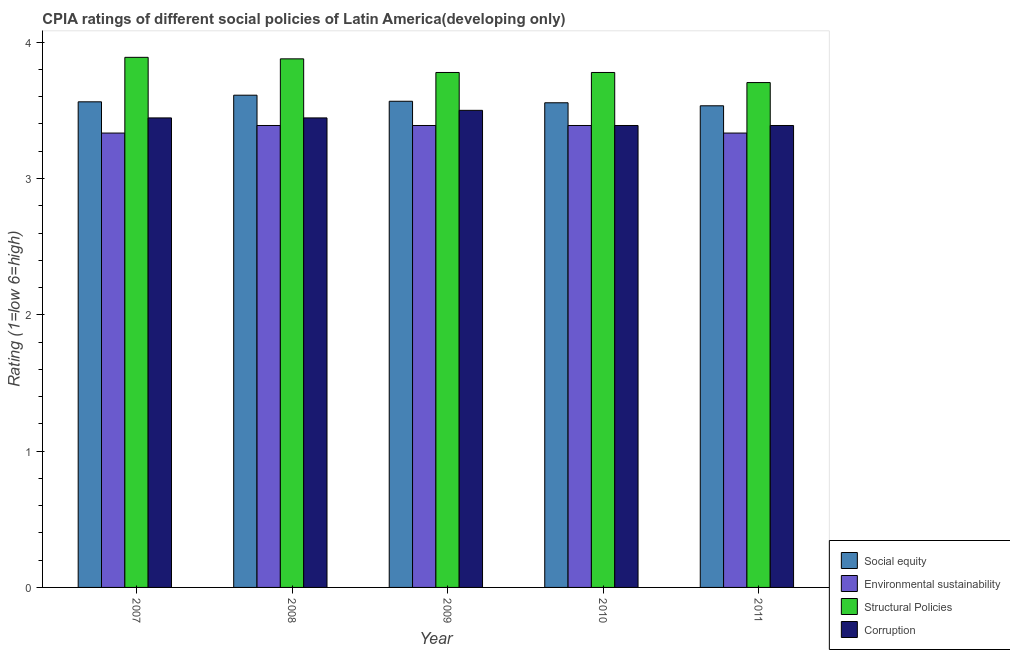How many different coloured bars are there?
Offer a very short reply. 4. Are the number of bars on each tick of the X-axis equal?
Your answer should be compact. Yes. What is the label of the 4th group of bars from the left?
Provide a succinct answer. 2010. In how many cases, is the number of bars for a given year not equal to the number of legend labels?
Keep it short and to the point. 0. What is the cpia rating of environmental sustainability in 2011?
Your answer should be compact. 3.33. Across all years, what is the maximum cpia rating of environmental sustainability?
Make the answer very short. 3.39. Across all years, what is the minimum cpia rating of corruption?
Provide a short and direct response. 3.39. In which year was the cpia rating of social equity maximum?
Provide a succinct answer. 2008. In which year was the cpia rating of structural policies minimum?
Your answer should be very brief. 2011. What is the total cpia rating of social equity in the graph?
Your response must be concise. 17.83. What is the difference between the cpia rating of social equity in 2009 and that in 2011?
Your answer should be compact. 0.03. What is the difference between the cpia rating of corruption in 2009 and the cpia rating of structural policies in 2007?
Your answer should be very brief. 0.06. What is the average cpia rating of corruption per year?
Provide a short and direct response. 3.43. In the year 2011, what is the difference between the cpia rating of social equity and cpia rating of structural policies?
Offer a terse response. 0. In how many years, is the cpia rating of environmental sustainability greater than 2.2?
Offer a terse response. 5. What is the ratio of the cpia rating of structural policies in 2009 to that in 2010?
Make the answer very short. 1. Is the cpia rating of social equity in 2007 less than that in 2010?
Keep it short and to the point. No. Is the difference between the cpia rating of social equity in 2008 and 2010 greater than the difference between the cpia rating of structural policies in 2008 and 2010?
Provide a succinct answer. No. What is the difference between the highest and the second highest cpia rating of corruption?
Your answer should be compact. 0.06. What is the difference between the highest and the lowest cpia rating of social equity?
Provide a succinct answer. 0.08. Is the sum of the cpia rating of social equity in 2007 and 2010 greater than the maximum cpia rating of structural policies across all years?
Provide a short and direct response. Yes. Is it the case that in every year, the sum of the cpia rating of environmental sustainability and cpia rating of structural policies is greater than the sum of cpia rating of social equity and cpia rating of corruption?
Give a very brief answer. No. What does the 3rd bar from the left in 2010 represents?
Give a very brief answer. Structural Policies. What does the 1st bar from the right in 2010 represents?
Keep it short and to the point. Corruption. Is it the case that in every year, the sum of the cpia rating of social equity and cpia rating of environmental sustainability is greater than the cpia rating of structural policies?
Your response must be concise. Yes. How many bars are there?
Make the answer very short. 20. How many years are there in the graph?
Give a very brief answer. 5. What is the difference between two consecutive major ticks on the Y-axis?
Your answer should be compact. 1. Does the graph contain any zero values?
Ensure brevity in your answer.  No. Does the graph contain grids?
Your response must be concise. No. Where does the legend appear in the graph?
Make the answer very short. Bottom right. How are the legend labels stacked?
Your answer should be very brief. Vertical. What is the title of the graph?
Your response must be concise. CPIA ratings of different social policies of Latin America(developing only). Does "International Development Association" appear as one of the legend labels in the graph?
Your answer should be compact. No. What is the label or title of the Y-axis?
Your answer should be very brief. Rating (1=low 6=high). What is the Rating (1=low 6=high) of Social equity in 2007?
Make the answer very short. 3.56. What is the Rating (1=low 6=high) of Environmental sustainability in 2007?
Make the answer very short. 3.33. What is the Rating (1=low 6=high) of Structural Policies in 2007?
Offer a very short reply. 3.89. What is the Rating (1=low 6=high) in Corruption in 2007?
Give a very brief answer. 3.44. What is the Rating (1=low 6=high) of Social equity in 2008?
Give a very brief answer. 3.61. What is the Rating (1=low 6=high) in Environmental sustainability in 2008?
Ensure brevity in your answer.  3.39. What is the Rating (1=low 6=high) of Structural Policies in 2008?
Offer a very short reply. 3.88. What is the Rating (1=low 6=high) of Corruption in 2008?
Offer a terse response. 3.44. What is the Rating (1=low 6=high) of Social equity in 2009?
Offer a terse response. 3.57. What is the Rating (1=low 6=high) of Environmental sustainability in 2009?
Keep it short and to the point. 3.39. What is the Rating (1=low 6=high) in Structural Policies in 2009?
Offer a very short reply. 3.78. What is the Rating (1=low 6=high) in Corruption in 2009?
Make the answer very short. 3.5. What is the Rating (1=low 6=high) of Social equity in 2010?
Your answer should be compact. 3.56. What is the Rating (1=low 6=high) of Environmental sustainability in 2010?
Keep it short and to the point. 3.39. What is the Rating (1=low 6=high) of Structural Policies in 2010?
Your answer should be very brief. 3.78. What is the Rating (1=low 6=high) of Corruption in 2010?
Your answer should be very brief. 3.39. What is the Rating (1=low 6=high) in Social equity in 2011?
Your answer should be compact. 3.53. What is the Rating (1=low 6=high) in Environmental sustainability in 2011?
Make the answer very short. 3.33. What is the Rating (1=low 6=high) in Structural Policies in 2011?
Offer a very short reply. 3.7. What is the Rating (1=low 6=high) in Corruption in 2011?
Offer a terse response. 3.39. Across all years, what is the maximum Rating (1=low 6=high) in Social equity?
Make the answer very short. 3.61. Across all years, what is the maximum Rating (1=low 6=high) of Environmental sustainability?
Provide a succinct answer. 3.39. Across all years, what is the maximum Rating (1=low 6=high) in Structural Policies?
Offer a very short reply. 3.89. Across all years, what is the maximum Rating (1=low 6=high) of Corruption?
Offer a terse response. 3.5. Across all years, what is the minimum Rating (1=low 6=high) of Social equity?
Your answer should be compact. 3.53. Across all years, what is the minimum Rating (1=low 6=high) in Environmental sustainability?
Offer a very short reply. 3.33. Across all years, what is the minimum Rating (1=low 6=high) of Structural Policies?
Provide a succinct answer. 3.7. Across all years, what is the minimum Rating (1=low 6=high) of Corruption?
Give a very brief answer. 3.39. What is the total Rating (1=low 6=high) in Social equity in the graph?
Ensure brevity in your answer.  17.83. What is the total Rating (1=low 6=high) in Environmental sustainability in the graph?
Keep it short and to the point. 16.83. What is the total Rating (1=low 6=high) of Structural Policies in the graph?
Provide a short and direct response. 19.03. What is the total Rating (1=low 6=high) of Corruption in the graph?
Provide a short and direct response. 17.17. What is the difference between the Rating (1=low 6=high) of Social equity in 2007 and that in 2008?
Your response must be concise. -0.05. What is the difference between the Rating (1=low 6=high) of Environmental sustainability in 2007 and that in 2008?
Offer a very short reply. -0.06. What is the difference between the Rating (1=low 6=high) of Structural Policies in 2007 and that in 2008?
Provide a succinct answer. 0.01. What is the difference between the Rating (1=low 6=high) of Corruption in 2007 and that in 2008?
Provide a short and direct response. 0. What is the difference between the Rating (1=low 6=high) of Social equity in 2007 and that in 2009?
Keep it short and to the point. -0. What is the difference between the Rating (1=low 6=high) of Environmental sustainability in 2007 and that in 2009?
Offer a terse response. -0.06. What is the difference between the Rating (1=low 6=high) in Structural Policies in 2007 and that in 2009?
Ensure brevity in your answer.  0.11. What is the difference between the Rating (1=low 6=high) of Corruption in 2007 and that in 2009?
Provide a short and direct response. -0.06. What is the difference between the Rating (1=low 6=high) in Social equity in 2007 and that in 2010?
Offer a very short reply. 0.01. What is the difference between the Rating (1=low 6=high) in Environmental sustainability in 2007 and that in 2010?
Give a very brief answer. -0.06. What is the difference between the Rating (1=low 6=high) in Structural Policies in 2007 and that in 2010?
Make the answer very short. 0.11. What is the difference between the Rating (1=low 6=high) in Corruption in 2007 and that in 2010?
Ensure brevity in your answer.  0.06. What is the difference between the Rating (1=low 6=high) of Social equity in 2007 and that in 2011?
Provide a short and direct response. 0.03. What is the difference between the Rating (1=low 6=high) of Environmental sustainability in 2007 and that in 2011?
Provide a short and direct response. 0. What is the difference between the Rating (1=low 6=high) in Structural Policies in 2007 and that in 2011?
Your response must be concise. 0.19. What is the difference between the Rating (1=low 6=high) in Corruption in 2007 and that in 2011?
Provide a short and direct response. 0.06. What is the difference between the Rating (1=low 6=high) in Social equity in 2008 and that in 2009?
Your answer should be very brief. 0.04. What is the difference between the Rating (1=low 6=high) of Corruption in 2008 and that in 2009?
Keep it short and to the point. -0.06. What is the difference between the Rating (1=low 6=high) in Social equity in 2008 and that in 2010?
Ensure brevity in your answer.  0.06. What is the difference between the Rating (1=low 6=high) of Structural Policies in 2008 and that in 2010?
Provide a succinct answer. 0.1. What is the difference between the Rating (1=low 6=high) in Corruption in 2008 and that in 2010?
Offer a terse response. 0.06. What is the difference between the Rating (1=low 6=high) in Social equity in 2008 and that in 2011?
Make the answer very short. 0.08. What is the difference between the Rating (1=low 6=high) of Environmental sustainability in 2008 and that in 2011?
Keep it short and to the point. 0.06. What is the difference between the Rating (1=low 6=high) in Structural Policies in 2008 and that in 2011?
Your answer should be very brief. 0.17. What is the difference between the Rating (1=low 6=high) of Corruption in 2008 and that in 2011?
Your answer should be very brief. 0.06. What is the difference between the Rating (1=low 6=high) of Social equity in 2009 and that in 2010?
Your response must be concise. 0.01. What is the difference between the Rating (1=low 6=high) in Corruption in 2009 and that in 2010?
Keep it short and to the point. 0.11. What is the difference between the Rating (1=low 6=high) in Environmental sustainability in 2009 and that in 2011?
Provide a succinct answer. 0.06. What is the difference between the Rating (1=low 6=high) in Structural Policies in 2009 and that in 2011?
Give a very brief answer. 0.07. What is the difference between the Rating (1=low 6=high) in Corruption in 2009 and that in 2011?
Provide a short and direct response. 0.11. What is the difference between the Rating (1=low 6=high) of Social equity in 2010 and that in 2011?
Your answer should be compact. 0.02. What is the difference between the Rating (1=low 6=high) in Environmental sustainability in 2010 and that in 2011?
Your response must be concise. 0.06. What is the difference between the Rating (1=low 6=high) of Structural Policies in 2010 and that in 2011?
Your response must be concise. 0.07. What is the difference between the Rating (1=low 6=high) of Social equity in 2007 and the Rating (1=low 6=high) of Environmental sustainability in 2008?
Your response must be concise. 0.17. What is the difference between the Rating (1=low 6=high) of Social equity in 2007 and the Rating (1=low 6=high) of Structural Policies in 2008?
Ensure brevity in your answer.  -0.32. What is the difference between the Rating (1=low 6=high) in Social equity in 2007 and the Rating (1=low 6=high) in Corruption in 2008?
Ensure brevity in your answer.  0.12. What is the difference between the Rating (1=low 6=high) in Environmental sustainability in 2007 and the Rating (1=low 6=high) in Structural Policies in 2008?
Provide a short and direct response. -0.54. What is the difference between the Rating (1=low 6=high) of Environmental sustainability in 2007 and the Rating (1=low 6=high) of Corruption in 2008?
Your response must be concise. -0.11. What is the difference between the Rating (1=low 6=high) of Structural Policies in 2007 and the Rating (1=low 6=high) of Corruption in 2008?
Ensure brevity in your answer.  0.44. What is the difference between the Rating (1=low 6=high) in Social equity in 2007 and the Rating (1=low 6=high) in Environmental sustainability in 2009?
Your response must be concise. 0.17. What is the difference between the Rating (1=low 6=high) in Social equity in 2007 and the Rating (1=low 6=high) in Structural Policies in 2009?
Your response must be concise. -0.22. What is the difference between the Rating (1=low 6=high) of Social equity in 2007 and the Rating (1=low 6=high) of Corruption in 2009?
Offer a very short reply. 0.06. What is the difference between the Rating (1=low 6=high) in Environmental sustainability in 2007 and the Rating (1=low 6=high) in Structural Policies in 2009?
Make the answer very short. -0.44. What is the difference between the Rating (1=low 6=high) of Environmental sustainability in 2007 and the Rating (1=low 6=high) of Corruption in 2009?
Provide a short and direct response. -0.17. What is the difference between the Rating (1=low 6=high) in Structural Policies in 2007 and the Rating (1=low 6=high) in Corruption in 2009?
Your response must be concise. 0.39. What is the difference between the Rating (1=low 6=high) of Social equity in 2007 and the Rating (1=low 6=high) of Environmental sustainability in 2010?
Your answer should be compact. 0.17. What is the difference between the Rating (1=low 6=high) of Social equity in 2007 and the Rating (1=low 6=high) of Structural Policies in 2010?
Offer a terse response. -0.22. What is the difference between the Rating (1=low 6=high) of Social equity in 2007 and the Rating (1=low 6=high) of Corruption in 2010?
Your answer should be compact. 0.17. What is the difference between the Rating (1=low 6=high) in Environmental sustainability in 2007 and the Rating (1=low 6=high) in Structural Policies in 2010?
Ensure brevity in your answer.  -0.44. What is the difference between the Rating (1=low 6=high) of Environmental sustainability in 2007 and the Rating (1=low 6=high) of Corruption in 2010?
Provide a short and direct response. -0.06. What is the difference between the Rating (1=low 6=high) in Structural Policies in 2007 and the Rating (1=low 6=high) in Corruption in 2010?
Your answer should be very brief. 0.5. What is the difference between the Rating (1=low 6=high) in Social equity in 2007 and the Rating (1=low 6=high) in Environmental sustainability in 2011?
Provide a succinct answer. 0.23. What is the difference between the Rating (1=low 6=high) of Social equity in 2007 and the Rating (1=low 6=high) of Structural Policies in 2011?
Provide a short and direct response. -0.14. What is the difference between the Rating (1=low 6=high) of Social equity in 2007 and the Rating (1=low 6=high) of Corruption in 2011?
Offer a terse response. 0.17. What is the difference between the Rating (1=low 6=high) in Environmental sustainability in 2007 and the Rating (1=low 6=high) in Structural Policies in 2011?
Offer a very short reply. -0.37. What is the difference between the Rating (1=low 6=high) of Environmental sustainability in 2007 and the Rating (1=low 6=high) of Corruption in 2011?
Keep it short and to the point. -0.06. What is the difference between the Rating (1=low 6=high) in Social equity in 2008 and the Rating (1=low 6=high) in Environmental sustainability in 2009?
Offer a terse response. 0.22. What is the difference between the Rating (1=low 6=high) in Environmental sustainability in 2008 and the Rating (1=low 6=high) in Structural Policies in 2009?
Your answer should be compact. -0.39. What is the difference between the Rating (1=low 6=high) of Environmental sustainability in 2008 and the Rating (1=low 6=high) of Corruption in 2009?
Offer a very short reply. -0.11. What is the difference between the Rating (1=low 6=high) in Structural Policies in 2008 and the Rating (1=low 6=high) in Corruption in 2009?
Offer a very short reply. 0.38. What is the difference between the Rating (1=low 6=high) of Social equity in 2008 and the Rating (1=low 6=high) of Environmental sustainability in 2010?
Give a very brief answer. 0.22. What is the difference between the Rating (1=low 6=high) of Social equity in 2008 and the Rating (1=low 6=high) of Corruption in 2010?
Your answer should be very brief. 0.22. What is the difference between the Rating (1=low 6=high) in Environmental sustainability in 2008 and the Rating (1=low 6=high) in Structural Policies in 2010?
Give a very brief answer. -0.39. What is the difference between the Rating (1=low 6=high) in Environmental sustainability in 2008 and the Rating (1=low 6=high) in Corruption in 2010?
Offer a very short reply. 0. What is the difference between the Rating (1=low 6=high) in Structural Policies in 2008 and the Rating (1=low 6=high) in Corruption in 2010?
Your answer should be compact. 0.49. What is the difference between the Rating (1=low 6=high) in Social equity in 2008 and the Rating (1=low 6=high) in Environmental sustainability in 2011?
Keep it short and to the point. 0.28. What is the difference between the Rating (1=low 6=high) in Social equity in 2008 and the Rating (1=low 6=high) in Structural Policies in 2011?
Offer a terse response. -0.09. What is the difference between the Rating (1=low 6=high) of Social equity in 2008 and the Rating (1=low 6=high) of Corruption in 2011?
Provide a short and direct response. 0.22. What is the difference between the Rating (1=low 6=high) in Environmental sustainability in 2008 and the Rating (1=low 6=high) in Structural Policies in 2011?
Provide a short and direct response. -0.31. What is the difference between the Rating (1=low 6=high) of Structural Policies in 2008 and the Rating (1=low 6=high) of Corruption in 2011?
Make the answer very short. 0.49. What is the difference between the Rating (1=low 6=high) in Social equity in 2009 and the Rating (1=low 6=high) in Environmental sustainability in 2010?
Your answer should be very brief. 0.18. What is the difference between the Rating (1=low 6=high) of Social equity in 2009 and the Rating (1=low 6=high) of Structural Policies in 2010?
Ensure brevity in your answer.  -0.21. What is the difference between the Rating (1=low 6=high) in Social equity in 2009 and the Rating (1=low 6=high) in Corruption in 2010?
Give a very brief answer. 0.18. What is the difference between the Rating (1=low 6=high) of Environmental sustainability in 2009 and the Rating (1=low 6=high) of Structural Policies in 2010?
Your answer should be very brief. -0.39. What is the difference between the Rating (1=low 6=high) in Structural Policies in 2009 and the Rating (1=low 6=high) in Corruption in 2010?
Your response must be concise. 0.39. What is the difference between the Rating (1=low 6=high) in Social equity in 2009 and the Rating (1=low 6=high) in Environmental sustainability in 2011?
Give a very brief answer. 0.23. What is the difference between the Rating (1=low 6=high) in Social equity in 2009 and the Rating (1=low 6=high) in Structural Policies in 2011?
Your answer should be very brief. -0.14. What is the difference between the Rating (1=low 6=high) of Social equity in 2009 and the Rating (1=low 6=high) of Corruption in 2011?
Provide a succinct answer. 0.18. What is the difference between the Rating (1=low 6=high) of Environmental sustainability in 2009 and the Rating (1=low 6=high) of Structural Policies in 2011?
Keep it short and to the point. -0.31. What is the difference between the Rating (1=low 6=high) of Structural Policies in 2009 and the Rating (1=low 6=high) of Corruption in 2011?
Your response must be concise. 0.39. What is the difference between the Rating (1=low 6=high) of Social equity in 2010 and the Rating (1=low 6=high) of Environmental sustainability in 2011?
Ensure brevity in your answer.  0.22. What is the difference between the Rating (1=low 6=high) of Social equity in 2010 and the Rating (1=low 6=high) of Structural Policies in 2011?
Your answer should be very brief. -0.15. What is the difference between the Rating (1=low 6=high) of Social equity in 2010 and the Rating (1=low 6=high) of Corruption in 2011?
Your response must be concise. 0.17. What is the difference between the Rating (1=low 6=high) in Environmental sustainability in 2010 and the Rating (1=low 6=high) in Structural Policies in 2011?
Give a very brief answer. -0.31. What is the difference between the Rating (1=low 6=high) in Environmental sustainability in 2010 and the Rating (1=low 6=high) in Corruption in 2011?
Ensure brevity in your answer.  0. What is the difference between the Rating (1=low 6=high) of Structural Policies in 2010 and the Rating (1=low 6=high) of Corruption in 2011?
Your answer should be compact. 0.39. What is the average Rating (1=low 6=high) in Social equity per year?
Your answer should be very brief. 3.57. What is the average Rating (1=low 6=high) in Environmental sustainability per year?
Provide a succinct answer. 3.37. What is the average Rating (1=low 6=high) of Structural Policies per year?
Give a very brief answer. 3.81. What is the average Rating (1=low 6=high) of Corruption per year?
Your response must be concise. 3.43. In the year 2007, what is the difference between the Rating (1=low 6=high) of Social equity and Rating (1=low 6=high) of Environmental sustainability?
Ensure brevity in your answer.  0.23. In the year 2007, what is the difference between the Rating (1=low 6=high) of Social equity and Rating (1=low 6=high) of Structural Policies?
Keep it short and to the point. -0.33. In the year 2007, what is the difference between the Rating (1=low 6=high) in Social equity and Rating (1=low 6=high) in Corruption?
Ensure brevity in your answer.  0.12. In the year 2007, what is the difference between the Rating (1=low 6=high) of Environmental sustainability and Rating (1=low 6=high) of Structural Policies?
Give a very brief answer. -0.56. In the year 2007, what is the difference between the Rating (1=low 6=high) of Environmental sustainability and Rating (1=low 6=high) of Corruption?
Keep it short and to the point. -0.11. In the year 2007, what is the difference between the Rating (1=low 6=high) of Structural Policies and Rating (1=low 6=high) of Corruption?
Offer a very short reply. 0.44. In the year 2008, what is the difference between the Rating (1=low 6=high) in Social equity and Rating (1=low 6=high) in Environmental sustainability?
Offer a terse response. 0.22. In the year 2008, what is the difference between the Rating (1=low 6=high) of Social equity and Rating (1=low 6=high) of Structural Policies?
Keep it short and to the point. -0.27. In the year 2008, what is the difference between the Rating (1=low 6=high) of Social equity and Rating (1=low 6=high) of Corruption?
Keep it short and to the point. 0.17. In the year 2008, what is the difference between the Rating (1=low 6=high) of Environmental sustainability and Rating (1=low 6=high) of Structural Policies?
Provide a short and direct response. -0.49. In the year 2008, what is the difference between the Rating (1=low 6=high) of Environmental sustainability and Rating (1=low 6=high) of Corruption?
Give a very brief answer. -0.06. In the year 2008, what is the difference between the Rating (1=low 6=high) of Structural Policies and Rating (1=low 6=high) of Corruption?
Provide a short and direct response. 0.43. In the year 2009, what is the difference between the Rating (1=low 6=high) in Social equity and Rating (1=low 6=high) in Environmental sustainability?
Your response must be concise. 0.18. In the year 2009, what is the difference between the Rating (1=low 6=high) of Social equity and Rating (1=low 6=high) of Structural Policies?
Your response must be concise. -0.21. In the year 2009, what is the difference between the Rating (1=low 6=high) in Social equity and Rating (1=low 6=high) in Corruption?
Offer a very short reply. 0.07. In the year 2009, what is the difference between the Rating (1=low 6=high) of Environmental sustainability and Rating (1=low 6=high) of Structural Policies?
Keep it short and to the point. -0.39. In the year 2009, what is the difference between the Rating (1=low 6=high) of Environmental sustainability and Rating (1=low 6=high) of Corruption?
Keep it short and to the point. -0.11. In the year 2009, what is the difference between the Rating (1=low 6=high) in Structural Policies and Rating (1=low 6=high) in Corruption?
Give a very brief answer. 0.28. In the year 2010, what is the difference between the Rating (1=low 6=high) of Social equity and Rating (1=low 6=high) of Structural Policies?
Make the answer very short. -0.22. In the year 2010, what is the difference between the Rating (1=low 6=high) in Social equity and Rating (1=low 6=high) in Corruption?
Give a very brief answer. 0.17. In the year 2010, what is the difference between the Rating (1=low 6=high) in Environmental sustainability and Rating (1=low 6=high) in Structural Policies?
Offer a terse response. -0.39. In the year 2010, what is the difference between the Rating (1=low 6=high) of Structural Policies and Rating (1=low 6=high) of Corruption?
Your response must be concise. 0.39. In the year 2011, what is the difference between the Rating (1=low 6=high) of Social equity and Rating (1=low 6=high) of Structural Policies?
Your answer should be compact. -0.17. In the year 2011, what is the difference between the Rating (1=low 6=high) in Social equity and Rating (1=low 6=high) in Corruption?
Your answer should be very brief. 0.14. In the year 2011, what is the difference between the Rating (1=low 6=high) of Environmental sustainability and Rating (1=low 6=high) of Structural Policies?
Make the answer very short. -0.37. In the year 2011, what is the difference between the Rating (1=low 6=high) in Environmental sustainability and Rating (1=low 6=high) in Corruption?
Your answer should be very brief. -0.06. In the year 2011, what is the difference between the Rating (1=low 6=high) of Structural Policies and Rating (1=low 6=high) of Corruption?
Give a very brief answer. 0.31. What is the ratio of the Rating (1=low 6=high) of Social equity in 2007 to that in 2008?
Offer a very short reply. 0.99. What is the ratio of the Rating (1=low 6=high) of Environmental sustainability in 2007 to that in 2008?
Provide a short and direct response. 0.98. What is the ratio of the Rating (1=low 6=high) in Environmental sustainability in 2007 to that in 2009?
Provide a succinct answer. 0.98. What is the ratio of the Rating (1=low 6=high) of Structural Policies in 2007 to that in 2009?
Your answer should be very brief. 1.03. What is the ratio of the Rating (1=low 6=high) of Corruption in 2007 to that in 2009?
Your response must be concise. 0.98. What is the ratio of the Rating (1=low 6=high) of Social equity in 2007 to that in 2010?
Make the answer very short. 1. What is the ratio of the Rating (1=low 6=high) of Environmental sustainability in 2007 to that in 2010?
Make the answer very short. 0.98. What is the ratio of the Rating (1=low 6=high) in Structural Policies in 2007 to that in 2010?
Your answer should be very brief. 1.03. What is the ratio of the Rating (1=low 6=high) of Corruption in 2007 to that in 2010?
Your answer should be very brief. 1.02. What is the ratio of the Rating (1=low 6=high) in Social equity in 2007 to that in 2011?
Give a very brief answer. 1.01. What is the ratio of the Rating (1=low 6=high) of Corruption in 2007 to that in 2011?
Offer a terse response. 1.02. What is the ratio of the Rating (1=low 6=high) of Social equity in 2008 to that in 2009?
Your response must be concise. 1.01. What is the ratio of the Rating (1=low 6=high) in Environmental sustainability in 2008 to that in 2009?
Your response must be concise. 1. What is the ratio of the Rating (1=low 6=high) of Structural Policies in 2008 to that in 2009?
Give a very brief answer. 1.03. What is the ratio of the Rating (1=low 6=high) of Corruption in 2008 to that in 2009?
Your response must be concise. 0.98. What is the ratio of the Rating (1=low 6=high) of Social equity in 2008 to that in 2010?
Your answer should be compact. 1.02. What is the ratio of the Rating (1=low 6=high) of Structural Policies in 2008 to that in 2010?
Provide a short and direct response. 1.03. What is the ratio of the Rating (1=low 6=high) of Corruption in 2008 to that in 2010?
Provide a short and direct response. 1.02. What is the ratio of the Rating (1=low 6=high) in Social equity in 2008 to that in 2011?
Make the answer very short. 1.02. What is the ratio of the Rating (1=low 6=high) of Environmental sustainability in 2008 to that in 2011?
Your answer should be very brief. 1.02. What is the ratio of the Rating (1=low 6=high) in Structural Policies in 2008 to that in 2011?
Offer a terse response. 1.05. What is the ratio of the Rating (1=low 6=high) of Corruption in 2008 to that in 2011?
Provide a succinct answer. 1.02. What is the ratio of the Rating (1=low 6=high) in Structural Policies in 2009 to that in 2010?
Your answer should be compact. 1. What is the ratio of the Rating (1=low 6=high) of Corruption in 2009 to that in 2010?
Provide a succinct answer. 1.03. What is the ratio of the Rating (1=low 6=high) in Social equity in 2009 to that in 2011?
Keep it short and to the point. 1.01. What is the ratio of the Rating (1=low 6=high) in Environmental sustainability in 2009 to that in 2011?
Give a very brief answer. 1.02. What is the ratio of the Rating (1=low 6=high) of Corruption in 2009 to that in 2011?
Offer a terse response. 1.03. What is the ratio of the Rating (1=low 6=high) of Environmental sustainability in 2010 to that in 2011?
Provide a short and direct response. 1.02. What is the difference between the highest and the second highest Rating (1=low 6=high) in Social equity?
Give a very brief answer. 0.04. What is the difference between the highest and the second highest Rating (1=low 6=high) of Environmental sustainability?
Provide a succinct answer. 0. What is the difference between the highest and the second highest Rating (1=low 6=high) of Structural Policies?
Give a very brief answer. 0.01. What is the difference between the highest and the second highest Rating (1=low 6=high) in Corruption?
Your answer should be compact. 0.06. What is the difference between the highest and the lowest Rating (1=low 6=high) in Social equity?
Your response must be concise. 0.08. What is the difference between the highest and the lowest Rating (1=low 6=high) in Environmental sustainability?
Provide a succinct answer. 0.06. What is the difference between the highest and the lowest Rating (1=low 6=high) in Structural Policies?
Offer a terse response. 0.19. 